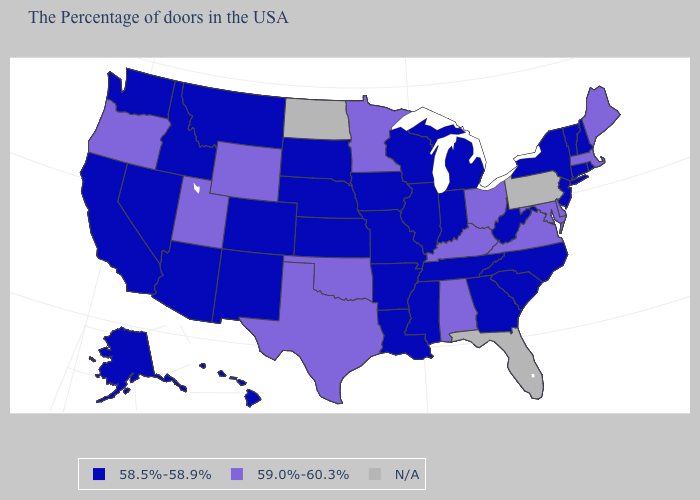Among the states that border California , which have the highest value?
Concise answer only. Oregon. What is the value of Missouri?
Answer briefly. 58.5%-58.9%. Which states have the highest value in the USA?
Be succinct. Maine, Massachusetts, Delaware, Maryland, Virginia, Ohio, Kentucky, Alabama, Minnesota, Oklahoma, Texas, Wyoming, Utah, Oregon. What is the value of Nevada?
Answer briefly. 58.5%-58.9%. Name the states that have a value in the range 58.5%-58.9%?
Write a very short answer. Rhode Island, New Hampshire, Vermont, Connecticut, New York, New Jersey, North Carolina, South Carolina, West Virginia, Georgia, Michigan, Indiana, Tennessee, Wisconsin, Illinois, Mississippi, Louisiana, Missouri, Arkansas, Iowa, Kansas, Nebraska, South Dakota, Colorado, New Mexico, Montana, Arizona, Idaho, Nevada, California, Washington, Alaska, Hawaii. Among the states that border Tennessee , which have the highest value?
Answer briefly. Virginia, Kentucky, Alabama. Name the states that have a value in the range N/A?
Quick response, please. Pennsylvania, Florida, North Dakota. Does Maryland have the highest value in the USA?
Write a very short answer. Yes. Does the map have missing data?
Be succinct. Yes. Which states hav the highest value in the South?
Give a very brief answer. Delaware, Maryland, Virginia, Kentucky, Alabama, Oklahoma, Texas. What is the value of Nevada?
Keep it brief. 58.5%-58.9%. Which states hav the highest value in the Northeast?
Keep it brief. Maine, Massachusetts. Name the states that have a value in the range 59.0%-60.3%?
Quick response, please. Maine, Massachusetts, Delaware, Maryland, Virginia, Ohio, Kentucky, Alabama, Minnesota, Oklahoma, Texas, Wyoming, Utah, Oregon. What is the value of Ohio?
Quick response, please. 59.0%-60.3%. What is the value of Louisiana?
Give a very brief answer. 58.5%-58.9%. 